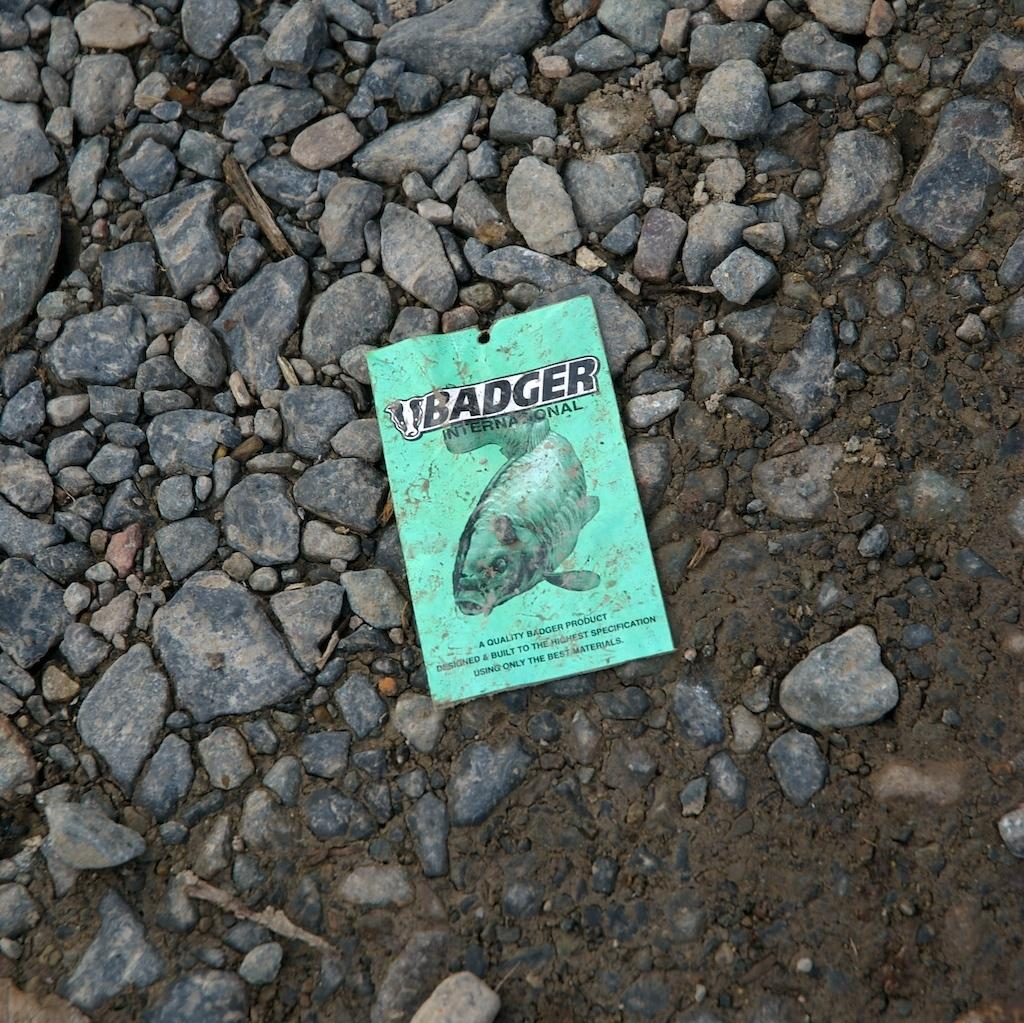What is featured on the poster in the image? There is a poster with text in the image. What image is depicted on the poster? There is a picture of a fish in the poster. How is the fish positioned in the picture? The fish is lying on stones in the picture. What type of brass instrument is being played by the dad in the image? There is no brass instrument or dad present in the image; it only features a poster with a picture of a fish lying on stones. 